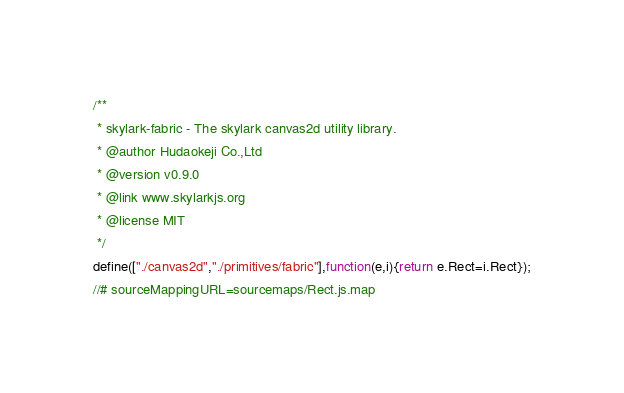Convert code to text. <code><loc_0><loc_0><loc_500><loc_500><_JavaScript_>/**
 * skylark-fabric - The skylark canvas2d utility library.
 * @author Hudaokeji Co.,Ltd
 * @version v0.9.0
 * @link www.skylarkjs.org
 * @license MIT
 */
define(["./canvas2d","./primitives/fabric"],function(e,i){return e.Rect=i.Rect});
//# sourceMappingURL=sourcemaps/Rect.js.map
</code> 